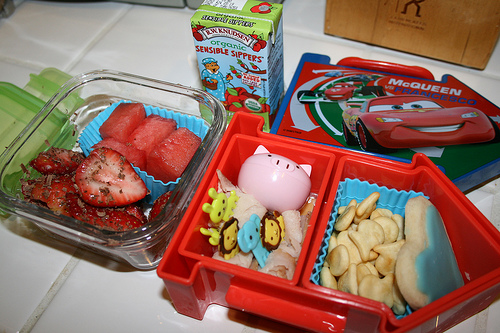<image>
Is there a goldfish crackers under the lunchbox topper? No. The goldfish crackers is not positioned under the lunchbox topper. The vertical relationship between these objects is different. Where is the food in relation to the box? Is it in the box? No. The food is not contained within the box. These objects have a different spatial relationship. 